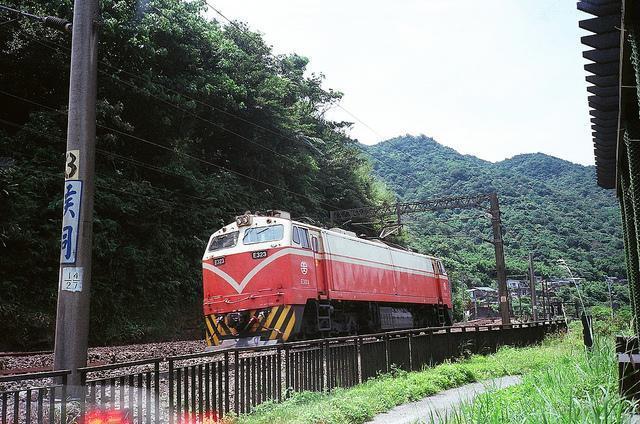How many trains are there?
Give a very brief answer. 1. How many of the benches on the boat have chains attached to them?
Give a very brief answer. 0. 